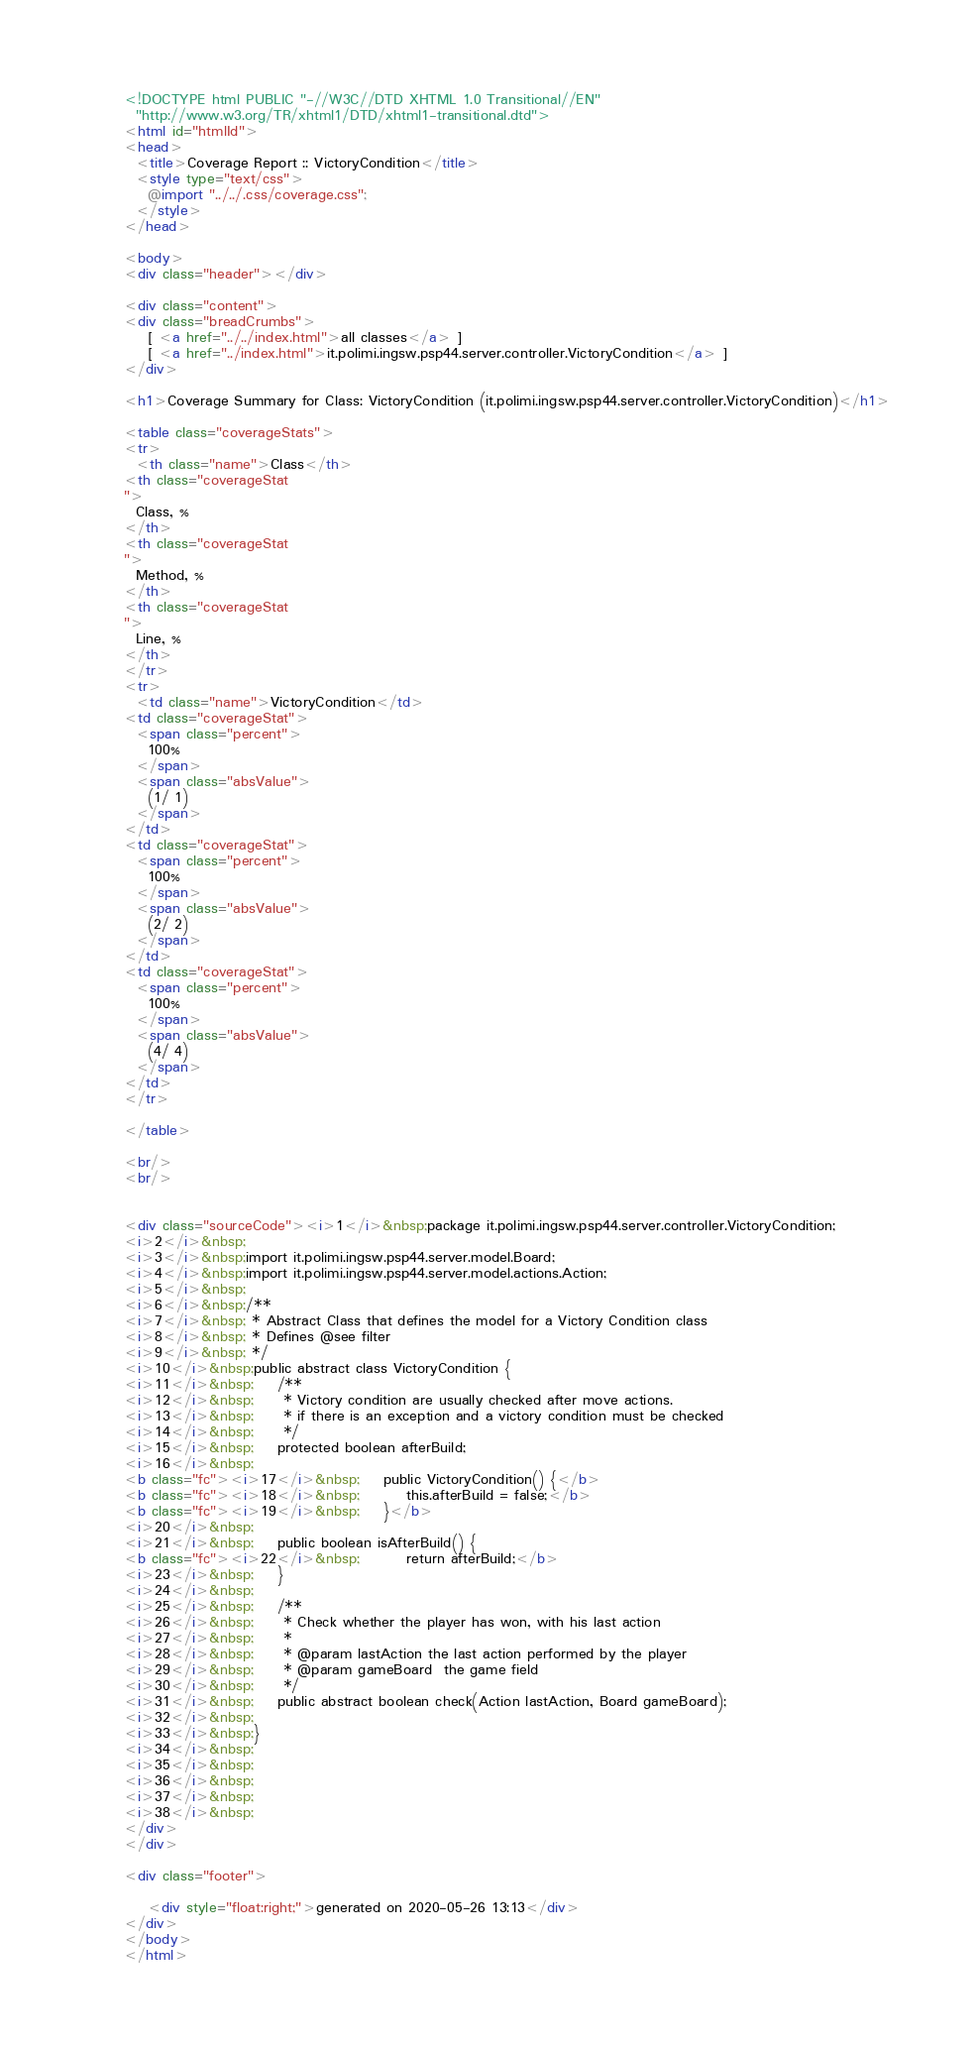<code> <loc_0><loc_0><loc_500><loc_500><_HTML_>


<!DOCTYPE html PUBLIC "-//W3C//DTD XHTML 1.0 Transitional//EN"
  "http://www.w3.org/TR/xhtml1/DTD/xhtml1-transitional.dtd">
<html id="htmlId">
<head>
  <title>Coverage Report :: VictoryCondition</title>
  <style type="text/css">
    @import "../../.css/coverage.css";
  </style>
</head>

<body>
<div class="header"></div>

<div class="content">
<div class="breadCrumbs">
    [ <a href="../../index.html">all classes</a> ]
    [ <a href="../index.html">it.polimi.ingsw.psp44.server.controller.VictoryCondition</a> ]
</div>

<h1>Coverage Summary for Class: VictoryCondition (it.polimi.ingsw.psp44.server.controller.VictoryCondition)</h1>

<table class="coverageStats">
<tr>
  <th class="name">Class</th>
<th class="coverageStat 
">
  Class, %
</th>
<th class="coverageStat 
">
  Method, %
</th>
<th class="coverageStat 
">
  Line, %
</th>
</tr>
<tr>
  <td class="name">VictoryCondition</td>
<td class="coverageStat">
  <span class="percent">
    100%
  </span>
  <span class="absValue">
    (1/ 1)
  </span>
</td>
<td class="coverageStat">
  <span class="percent">
    100%
  </span>
  <span class="absValue">
    (2/ 2)
  </span>
</td>
<td class="coverageStat">
  <span class="percent">
    100%
  </span>
  <span class="absValue">
    (4/ 4)
  </span>
</td>
</tr>

</table>

<br/>
<br/>


<div class="sourceCode"><i>1</i>&nbsp;package it.polimi.ingsw.psp44.server.controller.VictoryCondition;
<i>2</i>&nbsp;
<i>3</i>&nbsp;import it.polimi.ingsw.psp44.server.model.Board;
<i>4</i>&nbsp;import it.polimi.ingsw.psp44.server.model.actions.Action;
<i>5</i>&nbsp;
<i>6</i>&nbsp;/**
<i>7</i>&nbsp; * Abstract Class that defines the model for a Victory Condition class
<i>8</i>&nbsp; * Defines @see filter
<i>9</i>&nbsp; */
<i>10</i>&nbsp;public abstract class VictoryCondition {
<i>11</i>&nbsp;    /**
<i>12</i>&nbsp;     * Victory condition are usually checked after move actions.
<i>13</i>&nbsp;     * if there is an exception and a victory condition must be checked
<i>14</i>&nbsp;     */
<i>15</i>&nbsp;    protected boolean afterBuild;
<i>16</i>&nbsp;
<b class="fc"><i>17</i>&nbsp;    public VictoryCondition() {</b>
<b class="fc"><i>18</i>&nbsp;        this.afterBuild = false;</b>
<b class="fc"><i>19</i>&nbsp;    }</b>
<i>20</i>&nbsp;
<i>21</i>&nbsp;    public boolean isAfterBuild() {
<b class="fc"><i>22</i>&nbsp;        return afterBuild;</b>
<i>23</i>&nbsp;    }
<i>24</i>&nbsp;
<i>25</i>&nbsp;    /**
<i>26</i>&nbsp;     * Check whether the player has won, with his last action
<i>27</i>&nbsp;     *
<i>28</i>&nbsp;     * @param lastAction the last action performed by the player
<i>29</i>&nbsp;     * @param gameBoard  the game field
<i>30</i>&nbsp;     */
<i>31</i>&nbsp;    public abstract boolean check(Action lastAction, Board gameBoard);
<i>32</i>&nbsp;
<i>33</i>&nbsp;}
<i>34</i>&nbsp;
<i>35</i>&nbsp;
<i>36</i>&nbsp;
<i>37</i>&nbsp;
<i>38</i>&nbsp;
</div>
</div>

<div class="footer">
    
    <div style="float:right;">generated on 2020-05-26 13:13</div>
</div>
</body>
</html>
</code> 